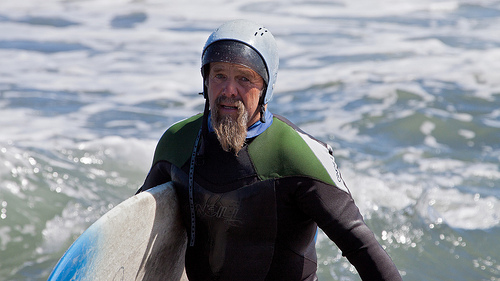How many colors are on the surfboard? The surfboard has a combination of 3 primary colors, which include white, blue, and a shade of black or dark grey, contributing to its aesthetic and functional design. 